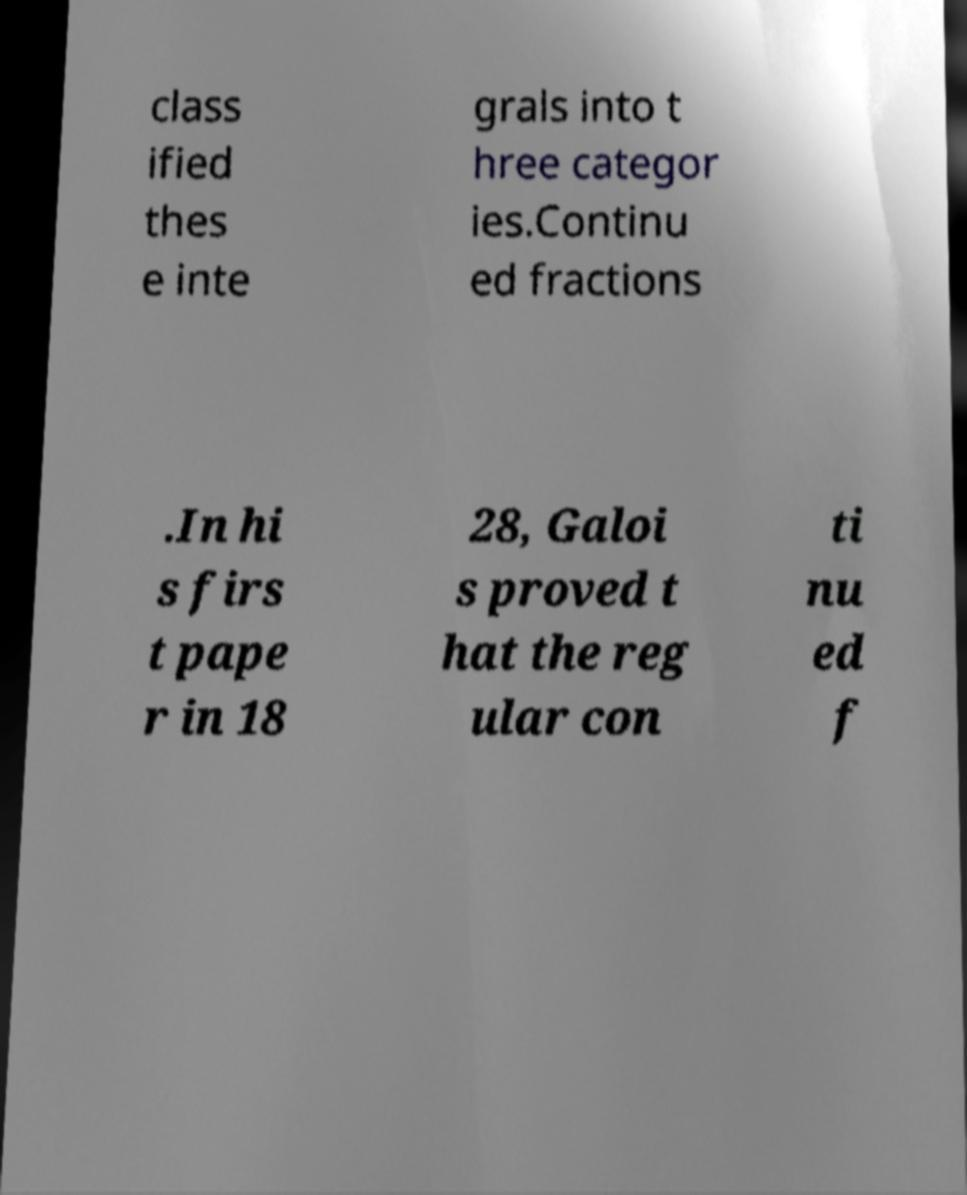Please identify and transcribe the text found in this image. class ified thes e inte grals into t hree categor ies.Continu ed fractions .In hi s firs t pape r in 18 28, Galoi s proved t hat the reg ular con ti nu ed f 